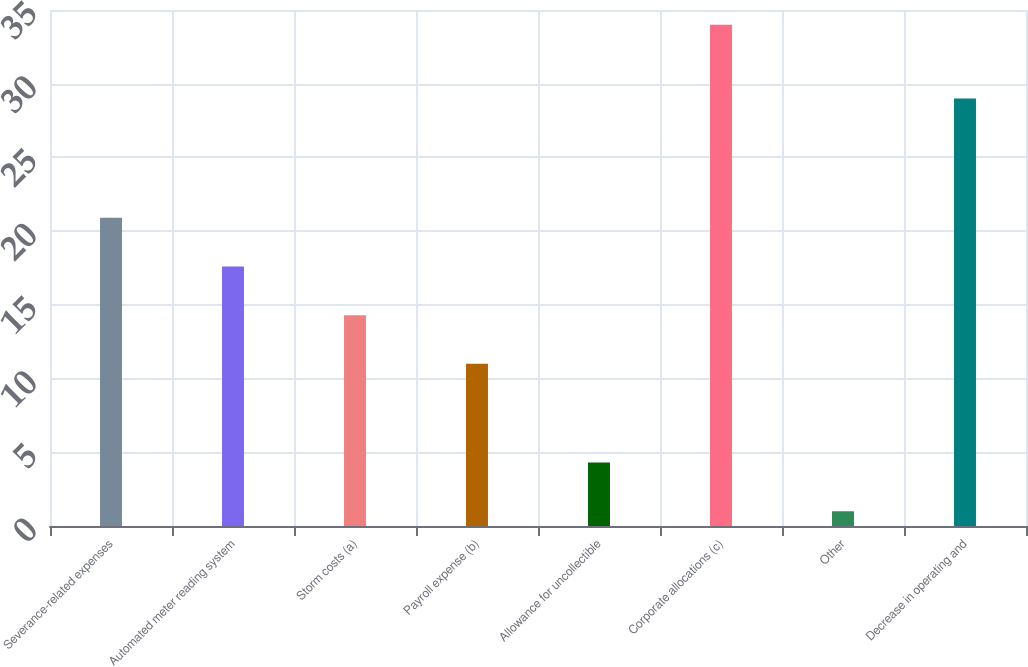<chart> <loc_0><loc_0><loc_500><loc_500><bar_chart><fcel>Severance-related expenses<fcel>Automated meter reading system<fcel>Storm costs (a)<fcel>Payroll expense (b)<fcel>Allowance for uncollectible<fcel>Corporate allocations (c)<fcel>Other<fcel>Decrease in operating and<nl><fcel>20.9<fcel>17.6<fcel>14.3<fcel>11<fcel>4.3<fcel>34<fcel>1<fcel>29<nl></chart> 